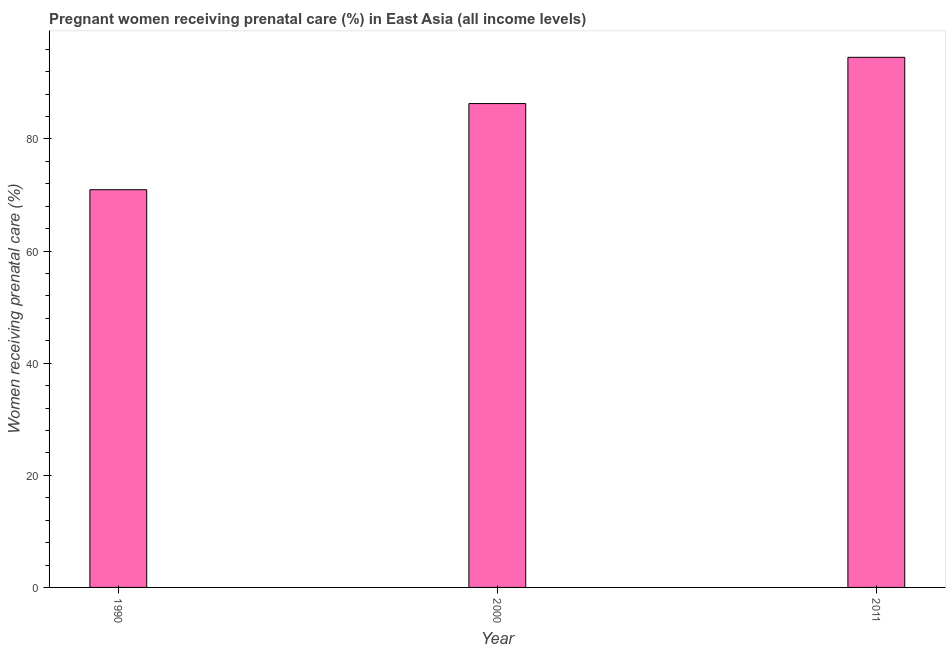Does the graph contain any zero values?
Provide a succinct answer. No. Does the graph contain grids?
Give a very brief answer. No. What is the title of the graph?
Offer a very short reply. Pregnant women receiving prenatal care (%) in East Asia (all income levels). What is the label or title of the X-axis?
Make the answer very short. Year. What is the label or title of the Y-axis?
Offer a very short reply. Women receiving prenatal care (%). What is the percentage of pregnant women receiving prenatal care in 1990?
Provide a succinct answer. 70.94. Across all years, what is the maximum percentage of pregnant women receiving prenatal care?
Keep it short and to the point. 94.56. Across all years, what is the minimum percentage of pregnant women receiving prenatal care?
Your answer should be very brief. 70.94. In which year was the percentage of pregnant women receiving prenatal care maximum?
Keep it short and to the point. 2011. In which year was the percentage of pregnant women receiving prenatal care minimum?
Ensure brevity in your answer.  1990. What is the sum of the percentage of pregnant women receiving prenatal care?
Keep it short and to the point. 251.82. What is the difference between the percentage of pregnant women receiving prenatal care in 1990 and 2011?
Give a very brief answer. -23.62. What is the average percentage of pregnant women receiving prenatal care per year?
Ensure brevity in your answer.  83.94. What is the median percentage of pregnant women receiving prenatal care?
Provide a short and direct response. 86.31. Do a majority of the years between 1990 and 2000 (inclusive) have percentage of pregnant women receiving prenatal care greater than 48 %?
Give a very brief answer. Yes. What is the ratio of the percentage of pregnant women receiving prenatal care in 1990 to that in 2000?
Keep it short and to the point. 0.82. Is the difference between the percentage of pregnant women receiving prenatal care in 1990 and 2000 greater than the difference between any two years?
Offer a terse response. No. What is the difference between the highest and the second highest percentage of pregnant women receiving prenatal care?
Offer a terse response. 8.25. Is the sum of the percentage of pregnant women receiving prenatal care in 1990 and 2000 greater than the maximum percentage of pregnant women receiving prenatal care across all years?
Your answer should be very brief. Yes. What is the difference between the highest and the lowest percentage of pregnant women receiving prenatal care?
Offer a terse response. 23.62. In how many years, is the percentage of pregnant women receiving prenatal care greater than the average percentage of pregnant women receiving prenatal care taken over all years?
Keep it short and to the point. 2. How many bars are there?
Ensure brevity in your answer.  3. Are all the bars in the graph horizontal?
Offer a terse response. No. Are the values on the major ticks of Y-axis written in scientific E-notation?
Keep it short and to the point. No. What is the Women receiving prenatal care (%) of 1990?
Provide a succinct answer. 70.94. What is the Women receiving prenatal care (%) in 2000?
Your answer should be compact. 86.31. What is the Women receiving prenatal care (%) of 2011?
Your answer should be very brief. 94.56. What is the difference between the Women receiving prenatal care (%) in 1990 and 2000?
Keep it short and to the point. -15.37. What is the difference between the Women receiving prenatal care (%) in 1990 and 2011?
Provide a short and direct response. -23.62. What is the difference between the Women receiving prenatal care (%) in 2000 and 2011?
Offer a terse response. -8.25. What is the ratio of the Women receiving prenatal care (%) in 1990 to that in 2000?
Ensure brevity in your answer.  0.82. 